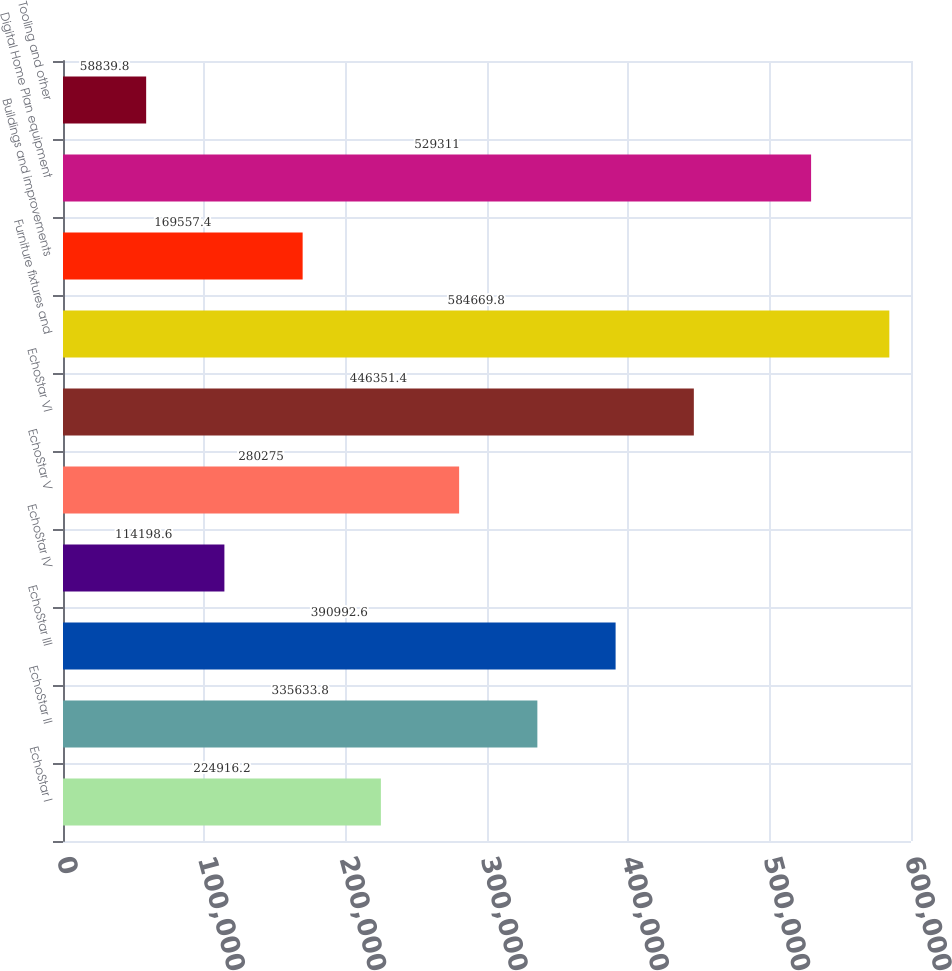Convert chart. <chart><loc_0><loc_0><loc_500><loc_500><bar_chart><fcel>EchoStar I<fcel>EchoStar II<fcel>EchoStar III<fcel>EchoStar IV<fcel>EchoStar V<fcel>EchoStar VI<fcel>Furniture fixtures and<fcel>Buildings and improvements<fcel>Digital Home Plan equipment<fcel>Tooling and other<nl><fcel>224916<fcel>335634<fcel>390993<fcel>114199<fcel>280275<fcel>446351<fcel>584670<fcel>169557<fcel>529311<fcel>58839.8<nl></chart> 